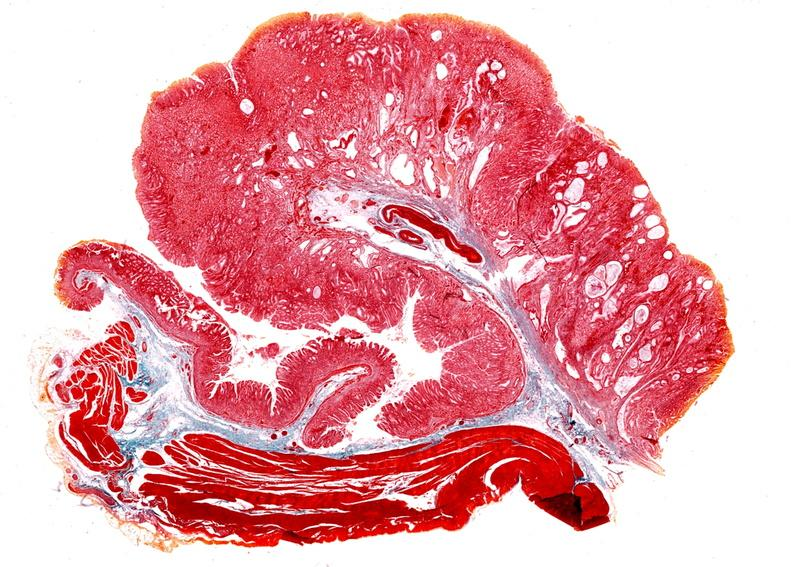what does this image show?
Answer the question using a single word or phrase. Stomach 